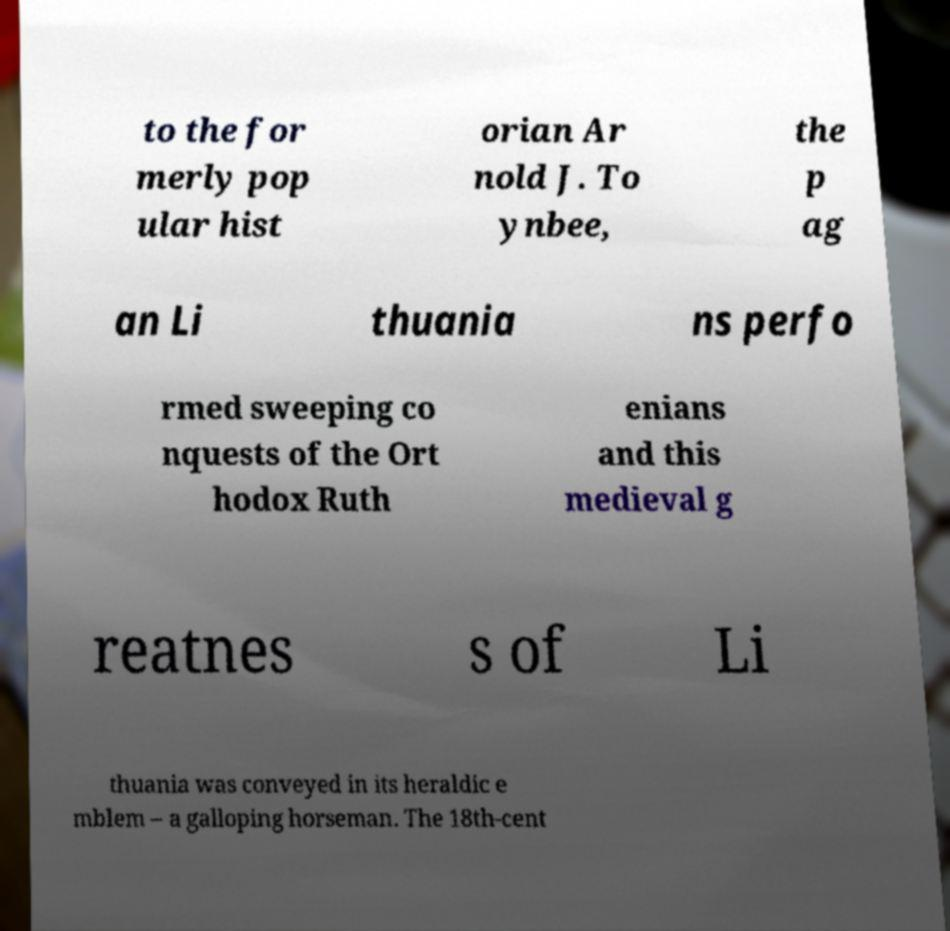Please read and relay the text visible in this image. What does it say? to the for merly pop ular hist orian Ar nold J. To ynbee, the p ag an Li thuania ns perfo rmed sweeping co nquests of the Ort hodox Ruth enians and this medieval g reatnes s of Li thuania was conveyed in its heraldic e mblem – a galloping horseman. The 18th-cent 